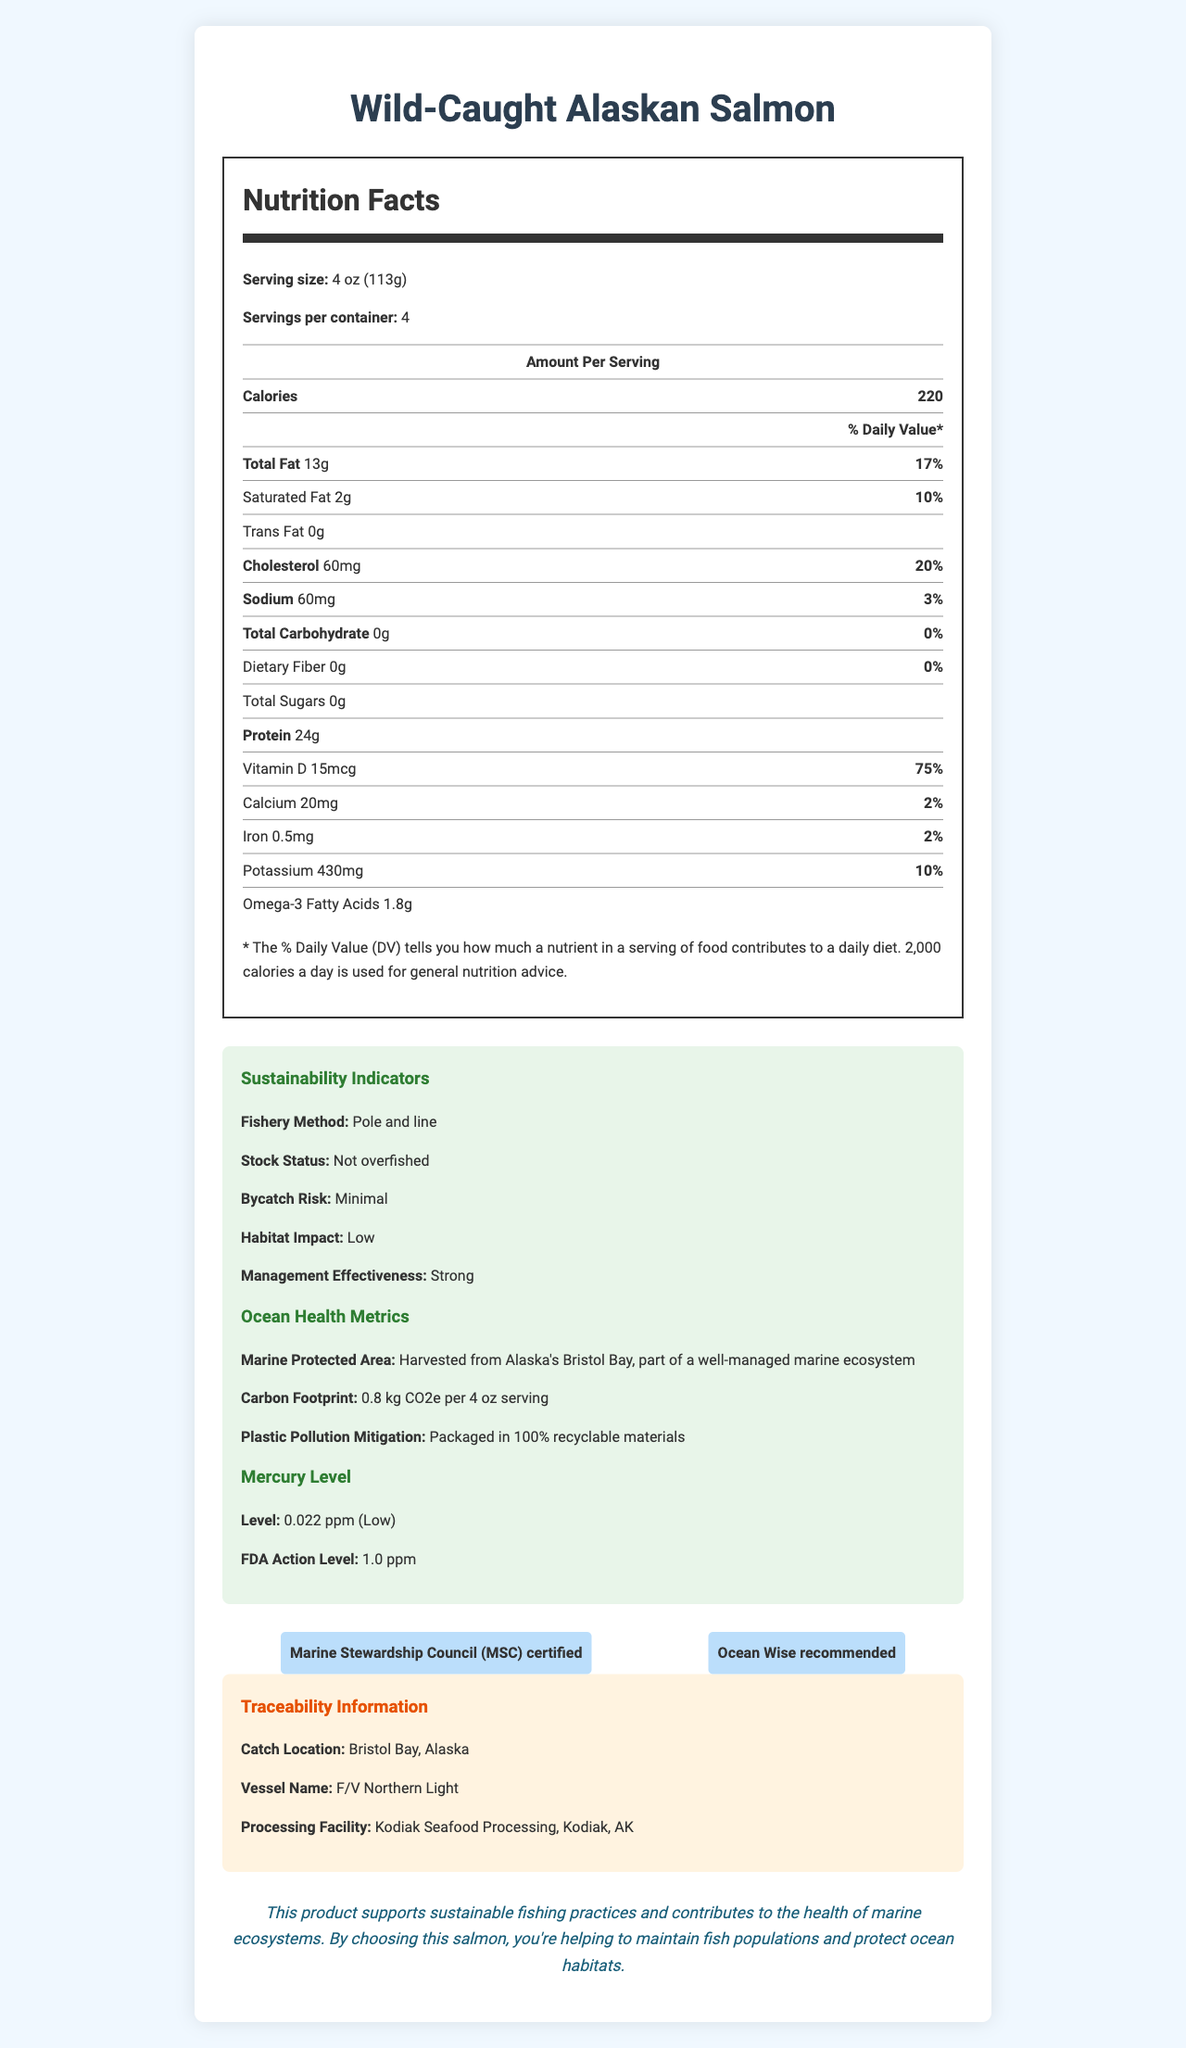what is the serving size? The serving size is listed at the top of the Nutrition Facts section: "Serving size: 4 oz (113g)".
Answer: 4 oz (113g) how many grams of protein are in one serving? In the Nutrition Facts section under the "Amount Per Serving" table, it states: "Protein 24g".
Answer: 24 grams what is the mercury level of this product in parts per million? The "Mercury Level" section specifies: "Level: 0.022 ppm (Low)".
Answer: 0.022 ppm how much Vitamin D does one serving provide, in micrograms? In the Nutrition Facts section under the "Amount Per Serving" table, it specifies: "Vitamin D 15mcg".
Answer: 15 micrograms which certifications does this product have? These certifications are listed in the "Certifications" section with each certification in a box: "Marine Stewardship Council (MSC) certified" and "Ocean Wise recommended".
Answer: Marine Stewardship Council (MSC) certified, Ocean Wise recommended what is the stock status of this fish product? The Sustainability Indicators section lists the stock status as "Not overfished".
Answer: Not overfished does this product contain any trans fat? The Nutrition Facts section under "Amount Per Serving" states: "Trans Fat 0g".
Answer: No what is the management effectiveness rating for this product? A. Weak B. Moderate C. Strong The Sustainability Indicators section states: "Management Effectiveness: Strong".
Answer: C. Strong how is this product’s bycatch risk rated? A. High B. Moderate C. Minimal The Sustainability Indicators section describes the bycatch risk as "Minimal".
Answer: C. Minimal which of the following environmental impacts is *not* mentioned in the document? A. Water usage B. Carbon footprint C. Plastic pollution mitigation D. Habitat impact The document mentions the carbon footprint, plastic pollution mitigation, and habitat impact, but does not mention water usage.
Answer: A. Water usage what is the "carbon footprint" per 4 oz serving of this product? The Ocean Health Metrics section notes: "Carbon Footprint: 0.8 kg CO2e per 4 oz serving".
Answer: 0.8 kg CO2e is the vessel used for catching this product mentioned? The Traceability Information section mentions: "Vessel Name: F/V Northern Light".
Answer: Yes summarize the entire document The document is detailed in structure, highlighting key aspects of the product's nutritional and environmental attributes, ensuring consumers are well informed about their purchase's impacts.
Answer: This document provides detailed information on the nutritional content, sustainability, and traceability of the Wild-Caught Alaskan Salmon product. It includes nutritional facts such as protein, fat, and vitamin content, sustainability indicators including fishing methods and stock status, ocean health metrics like carbon footprint and plastic pollution mitigation, and certifications such as MSC and Ocean Wise. It also outlines the mercury level and provides traceability information including catch location and vessel name. The document concludes with a statement on the product’s contribution to sustainable fishing and marine ecosystem health. where was the fish processed? The Traceability Information section notes the processing facility location: "Kodiak Seafood Processing, Kodiak, AK".
Answer: Kodiak Seafood Processing, Kodiak, AK what is the carbon footprint per container, assuming all servings are consumed? Each serving has a carbon footprint of 0.8 kg CO2e. With 4 servings per container, the total carbon footprint for the container would be 0.8 kg CO2e × 4 = 3.2 kg CO2e.
Answer: 3.2 kg CO2e what's the fishing method used for this product and why is it significant for sustainability? The Sustainability Indicators section states: "Fishery Method: Pole and line." This method is significant because it generally leads to lower bycatch and less environmental impact compared to other fishing methods.
Answer: Pole and line does the document provide information on the water usage in the production of this fish product? The document does not mention water usage; it focuses on carbon footprint, plastic pollution mitigation, and other sustainability indicators.
Answer: No 